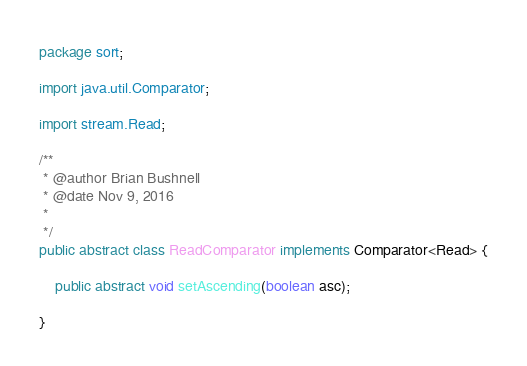<code> <loc_0><loc_0><loc_500><loc_500><_Java_>package sort;

import java.util.Comparator;

import stream.Read;

/**
 * @author Brian Bushnell
 * @date Nov 9, 2016
 *
 */
public abstract class ReadComparator implements Comparator<Read> {
	
	public abstract void setAscending(boolean asc);
	
}
</code> 